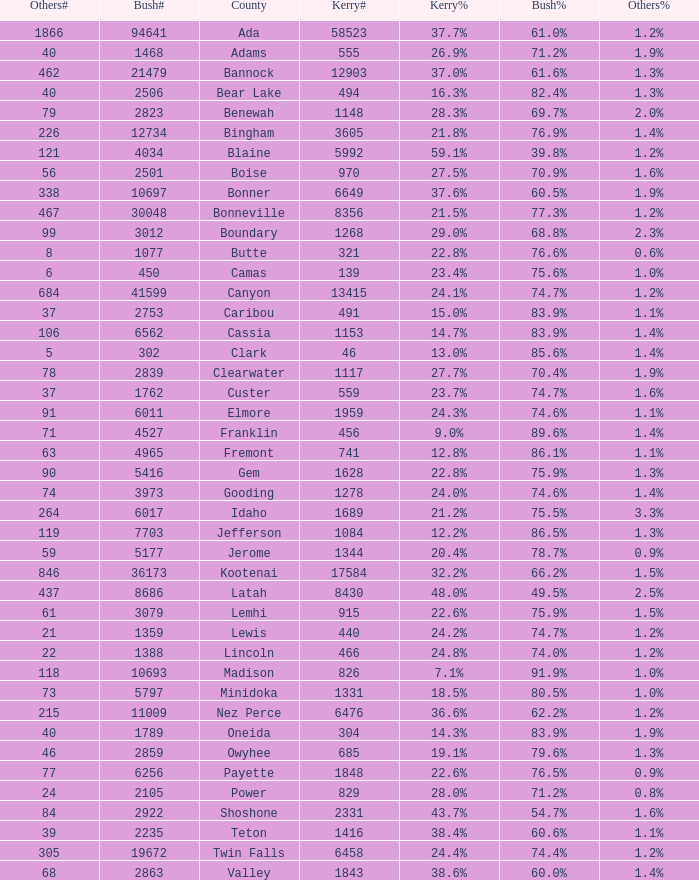How many different counts of the votes for Bush are there in the county where he got 69.7% of the votes? 1.0. 